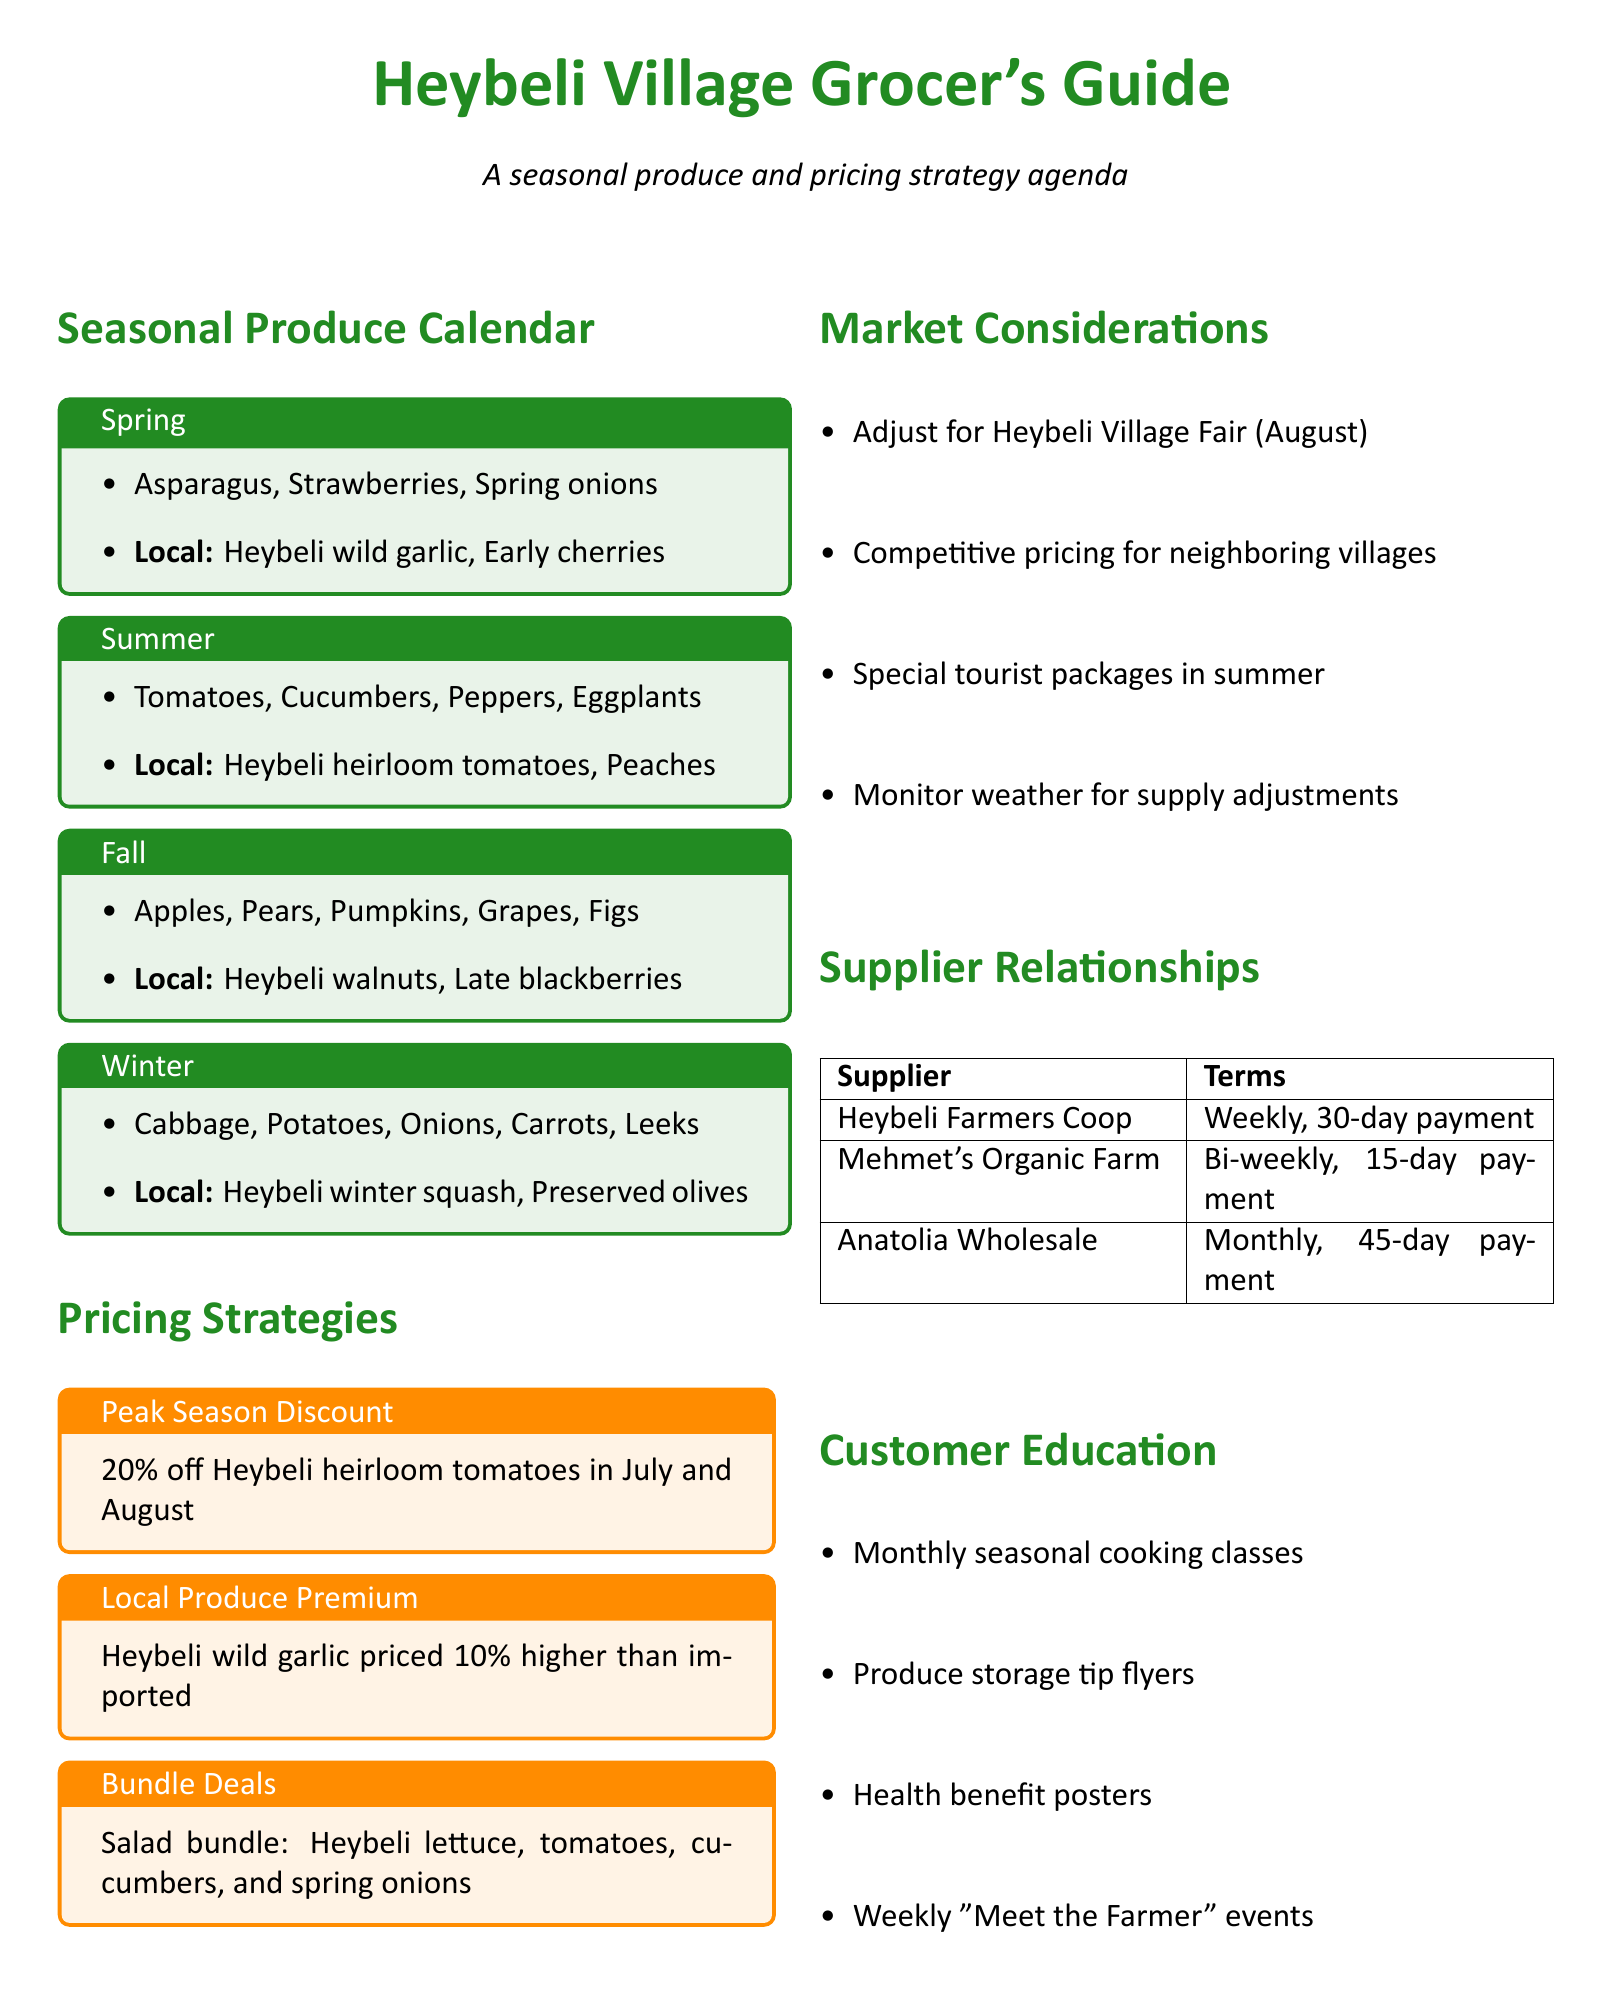What produce is available in Winter? The document lists the produce available in Winter, which includes cabbage, potatoes, onions, carrots, and leeks.
Answer: cabbage, potatoes, onions, carrots, leeks What is the local specialty for Spring? The document mentions local specialties for each season, and for Spring, it is Heybeli wild garlic and early season cherries.
Answer: Heybeli wild garlic, early season cherries What price discount is offered during peak season for Heybeli heirloom tomatoes? The document specifies a 20% discount for Heybeli heirloom tomatoes during peak season in July and August.
Answer: 20% What is the term for deliveries from Mehmet's Organic Farm? The document provides terms of delivery for each supplier, and for Mehmet's Organic Farm, the term is bi-weekly deliveries with a 15-day payment period.
Answer: bi-weekly, 15-day payment Which pricing strategy includes a themed bundle? The document discusses various pricing strategies, and the one that includes a themed bundle is "Bundle Deals."
Answer: Bundle Deals What local factor impacts pricing during the annual fair? The document states that the Heybeli Village Fair impacts pricing during its occurrence in August.
Answer: Heybeli Village Fair How often are deliveries from Anatolia Wholesale Produce? The document indicates that deliveries from Anatolia Wholesale Produce occur monthly.
Answer: monthly What type of classes are offered for customer education? The document mentions that seasonal cooking classes are provided for customer education.
Answer: Seasonal cooking classes 